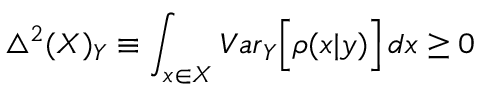Convert formula to latex. <formula><loc_0><loc_0><loc_500><loc_500>\bigtriangleup ^ { 2 } ( X ) _ { Y } \equiv \int _ { x \in X } { V a r } _ { Y } \left [ \rho ( x | y ) \right ] \, d x \geq 0</formula> 